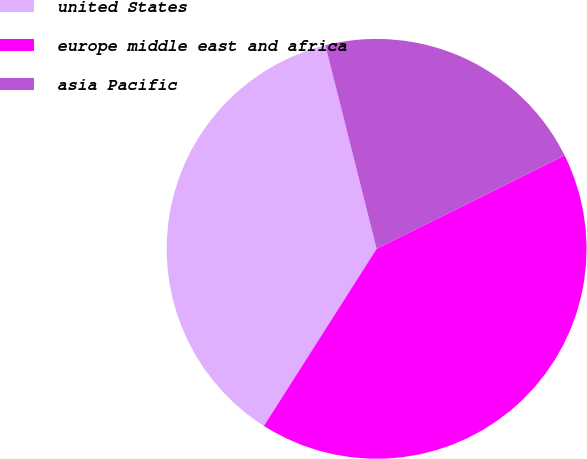<chart> <loc_0><loc_0><loc_500><loc_500><pie_chart><fcel>united States<fcel>europe middle east and africa<fcel>asia Pacific<nl><fcel>37.05%<fcel>41.36%<fcel>21.59%<nl></chart> 